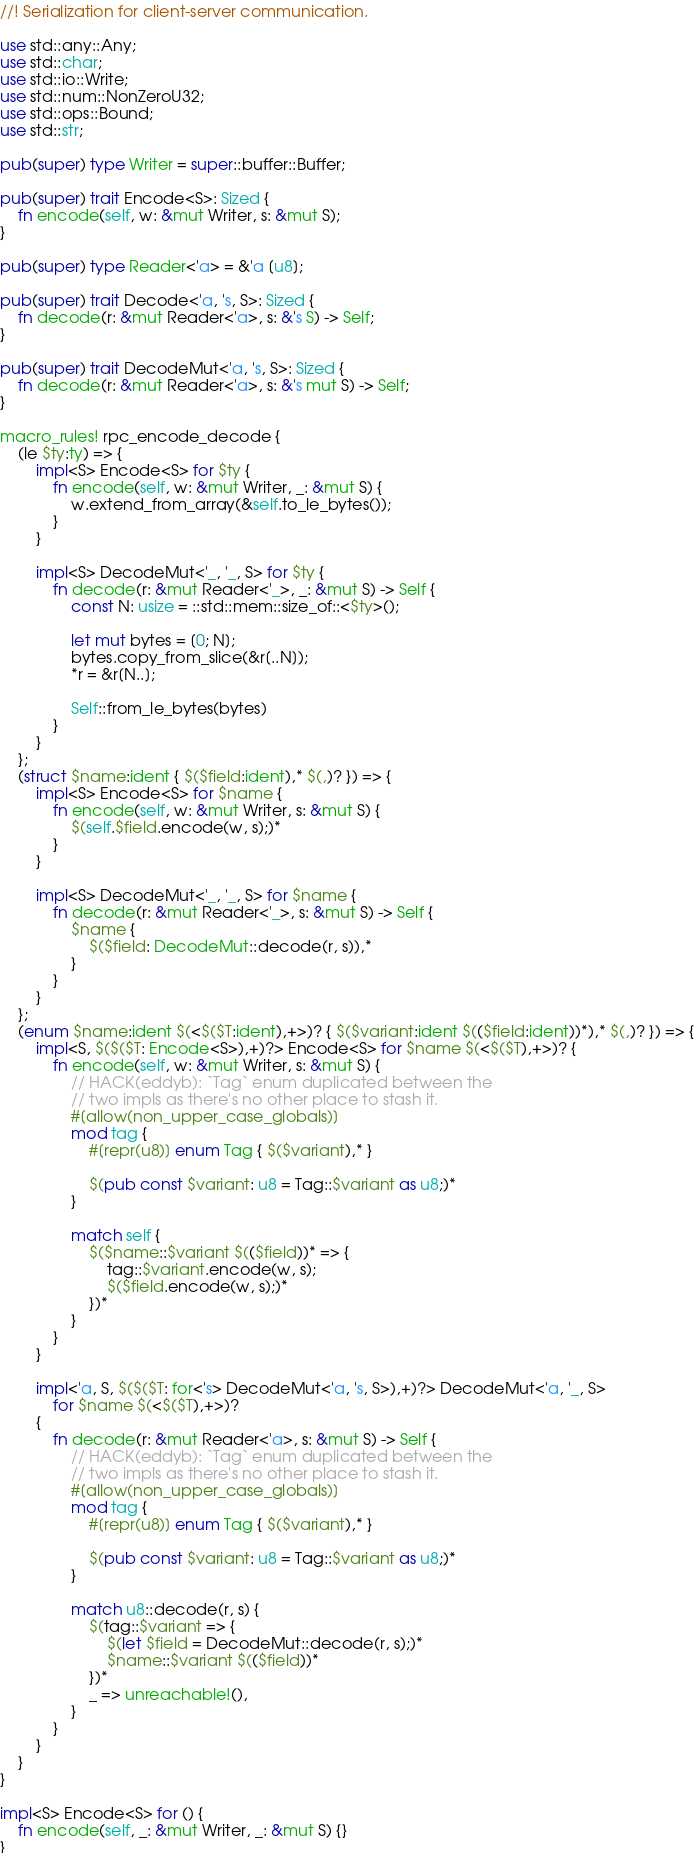Convert code to text. <code><loc_0><loc_0><loc_500><loc_500><_Rust_>//! Serialization for client-server communication.

use std::any::Any;
use std::char;
use std::io::Write;
use std::num::NonZeroU32;
use std::ops::Bound;
use std::str;

pub(super) type Writer = super::buffer::Buffer;

pub(super) trait Encode<S>: Sized {
    fn encode(self, w: &mut Writer, s: &mut S);
}

pub(super) type Reader<'a> = &'a [u8];

pub(super) trait Decode<'a, 's, S>: Sized {
    fn decode(r: &mut Reader<'a>, s: &'s S) -> Self;
}

pub(super) trait DecodeMut<'a, 's, S>: Sized {
    fn decode(r: &mut Reader<'a>, s: &'s mut S) -> Self;
}

macro_rules! rpc_encode_decode {
    (le $ty:ty) => {
        impl<S> Encode<S> for $ty {
            fn encode(self, w: &mut Writer, _: &mut S) {
                w.extend_from_array(&self.to_le_bytes());
            }
        }

        impl<S> DecodeMut<'_, '_, S> for $ty {
            fn decode(r: &mut Reader<'_>, _: &mut S) -> Self {
                const N: usize = ::std::mem::size_of::<$ty>();

                let mut bytes = [0; N];
                bytes.copy_from_slice(&r[..N]);
                *r = &r[N..];

                Self::from_le_bytes(bytes)
            }
        }
    };
    (struct $name:ident { $($field:ident),* $(,)? }) => {
        impl<S> Encode<S> for $name {
            fn encode(self, w: &mut Writer, s: &mut S) {
                $(self.$field.encode(w, s);)*
            }
        }

        impl<S> DecodeMut<'_, '_, S> for $name {
            fn decode(r: &mut Reader<'_>, s: &mut S) -> Self {
                $name {
                    $($field: DecodeMut::decode(r, s)),*
                }
            }
        }
    };
    (enum $name:ident $(<$($T:ident),+>)? { $($variant:ident $(($field:ident))*),* $(,)? }) => {
        impl<S, $($($T: Encode<S>),+)?> Encode<S> for $name $(<$($T),+>)? {
            fn encode(self, w: &mut Writer, s: &mut S) {
                // HACK(eddyb): `Tag` enum duplicated between the
                // two impls as there's no other place to stash it.
                #[allow(non_upper_case_globals)]
                mod tag {
                    #[repr(u8)] enum Tag { $($variant),* }

                    $(pub const $variant: u8 = Tag::$variant as u8;)*
                }

                match self {
                    $($name::$variant $(($field))* => {
                        tag::$variant.encode(w, s);
                        $($field.encode(w, s);)*
                    })*
                }
            }
        }

        impl<'a, S, $($($T: for<'s> DecodeMut<'a, 's, S>),+)?> DecodeMut<'a, '_, S>
            for $name $(<$($T),+>)?
        {
            fn decode(r: &mut Reader<'a>, s: &mut S) -> Self {
                // HACK(eddyb): `Tag` enum duplicated between the
                // two impls as there's no other place to stash it.
                #[allow(non_upper_case_globals)]
                mod tag {
                    #[repr(u8)] enum Tag { $($variant),* }

                    $(pub const $variant: u8 = Tag::$variant as u8;)*
                }

                match u8::decode(r, s) {
                    $(tag::$variant => {
                        $(let $field = DecodeMut::decode(r, s);)*
                        $name::$variant $(($field))*
                    })*
                    _ => unreachable!(),
                }
            }
        }
    }
}

impl<S> Encode<S> for () {
    fn encode(self, _: &mut Writer, _: &mut S) {}
}
</code> 